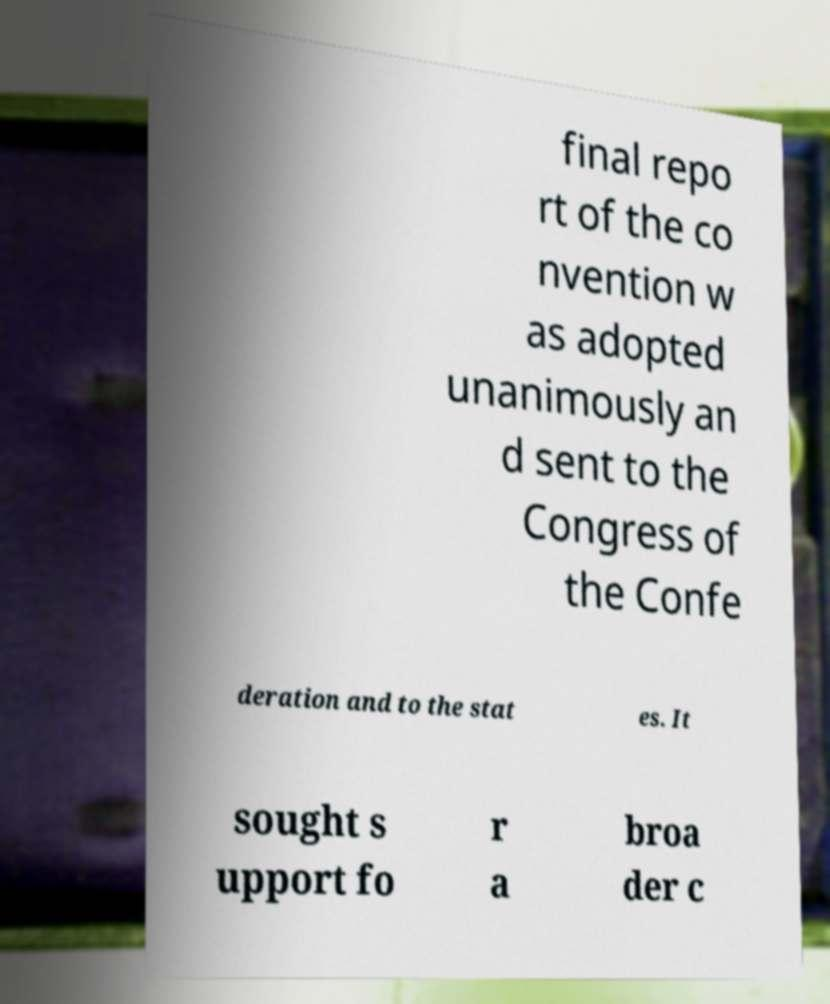I need the written content from this picture converted into text. Can you do that? final repo rt of the co nvention w as adopted unanimously an d sent to the Congress of the Confe deration and to the stat es. It sought s upport fo r a broa der c 